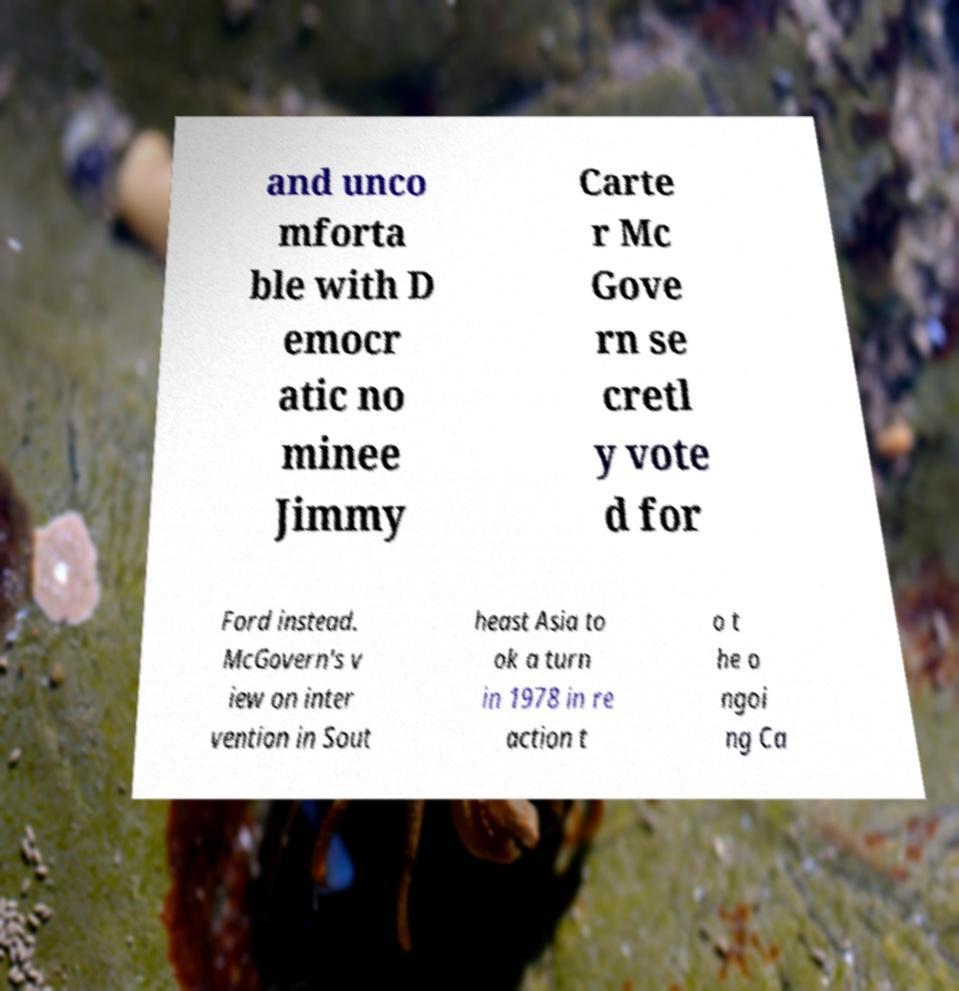What messages or text are displayed in this image? I need them in a readable, typed format. and unco mforta ble with D emocr atic no minee Jimmy Carte r Mc Gove rn se cretl y vote d for Ford instead. McGovern's v iew on inter vention in Sout heast Asia to ok a turn in 1978 in re action t o t he o ngoi ng Ca 